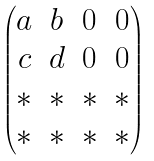<formula> <loc_0><loc_0><loc_500><loc_500>\begin{pmatrix} a & b & 0 & 0 \\ c & d & 0 & 0 \\ * & * & * & * \\ * & * & * & * \end{pmatrix}</formula> 